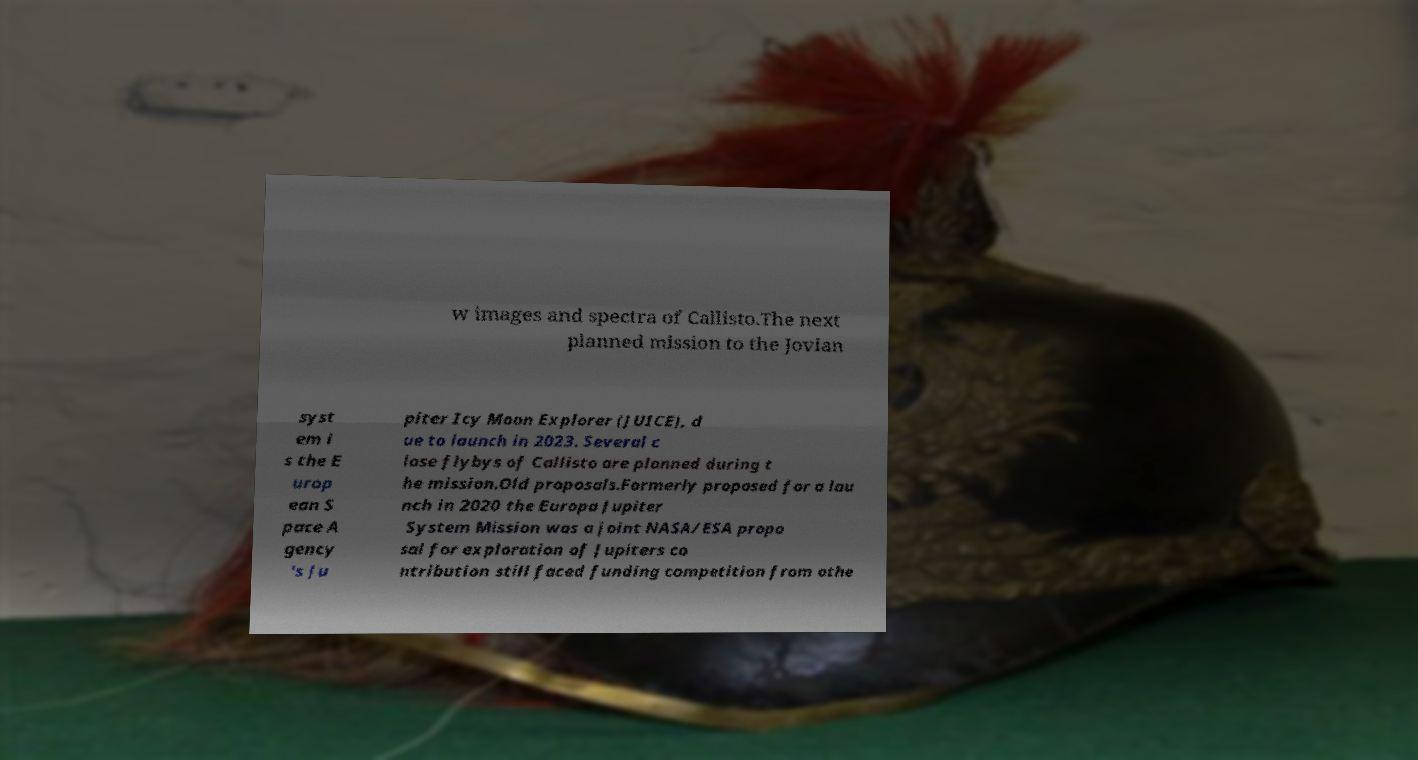Can you accurately transcribe the text from the provided image for me? w images and spectra of Callisto.The next planned mission to the Jovian syst em i s the E urop ean S pace A gency 's Ju piter Icy Moon Explorer (JUICE), d ue to launch in 2023. Several c lose flybys of Callisto are planned during t he mission.Old proposals.Formerly proposed for a lau nch in 2020 the Europa Jupiter System Mission was a joint NASA/ESA propo sal for exploration of Jupiters co ntribution still faced funding competition from othe 